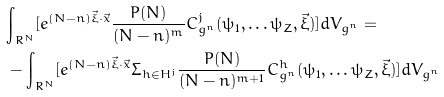<formula> <loc_0><loc_0><loc_500><loc_500>& { \int } _ { R ^ { N } } [ e ^ { ( N - n ) \vec { \xi } \cdot \vec { x } } \frac { P ( N ) } { ( N - n ) ^ { m } } C ^ { j } _ { g ^ { n } } ( { \psi } _ { 1 } , \dots { \psi } _ { Z } , \vec { \xi } ) ] d V _ { g ^ { n } } = \\ & - { \int } _ { R ^ { N } } [ e ^ { ( N - n ) \vec { \xi } \cdot \vec { x } } { \Sigma } _ { h \in H ^ { j } } \frac { P ( N ) } { ( N - n ) ^ { m + 1 } } C ^ { h } _ { g ^ { n } } ( { \psi } _ { 1 } , \dots { \psi } _ { Z } , \vec { \xi } ) ] d V _ { g ^ { n } }</formula> 